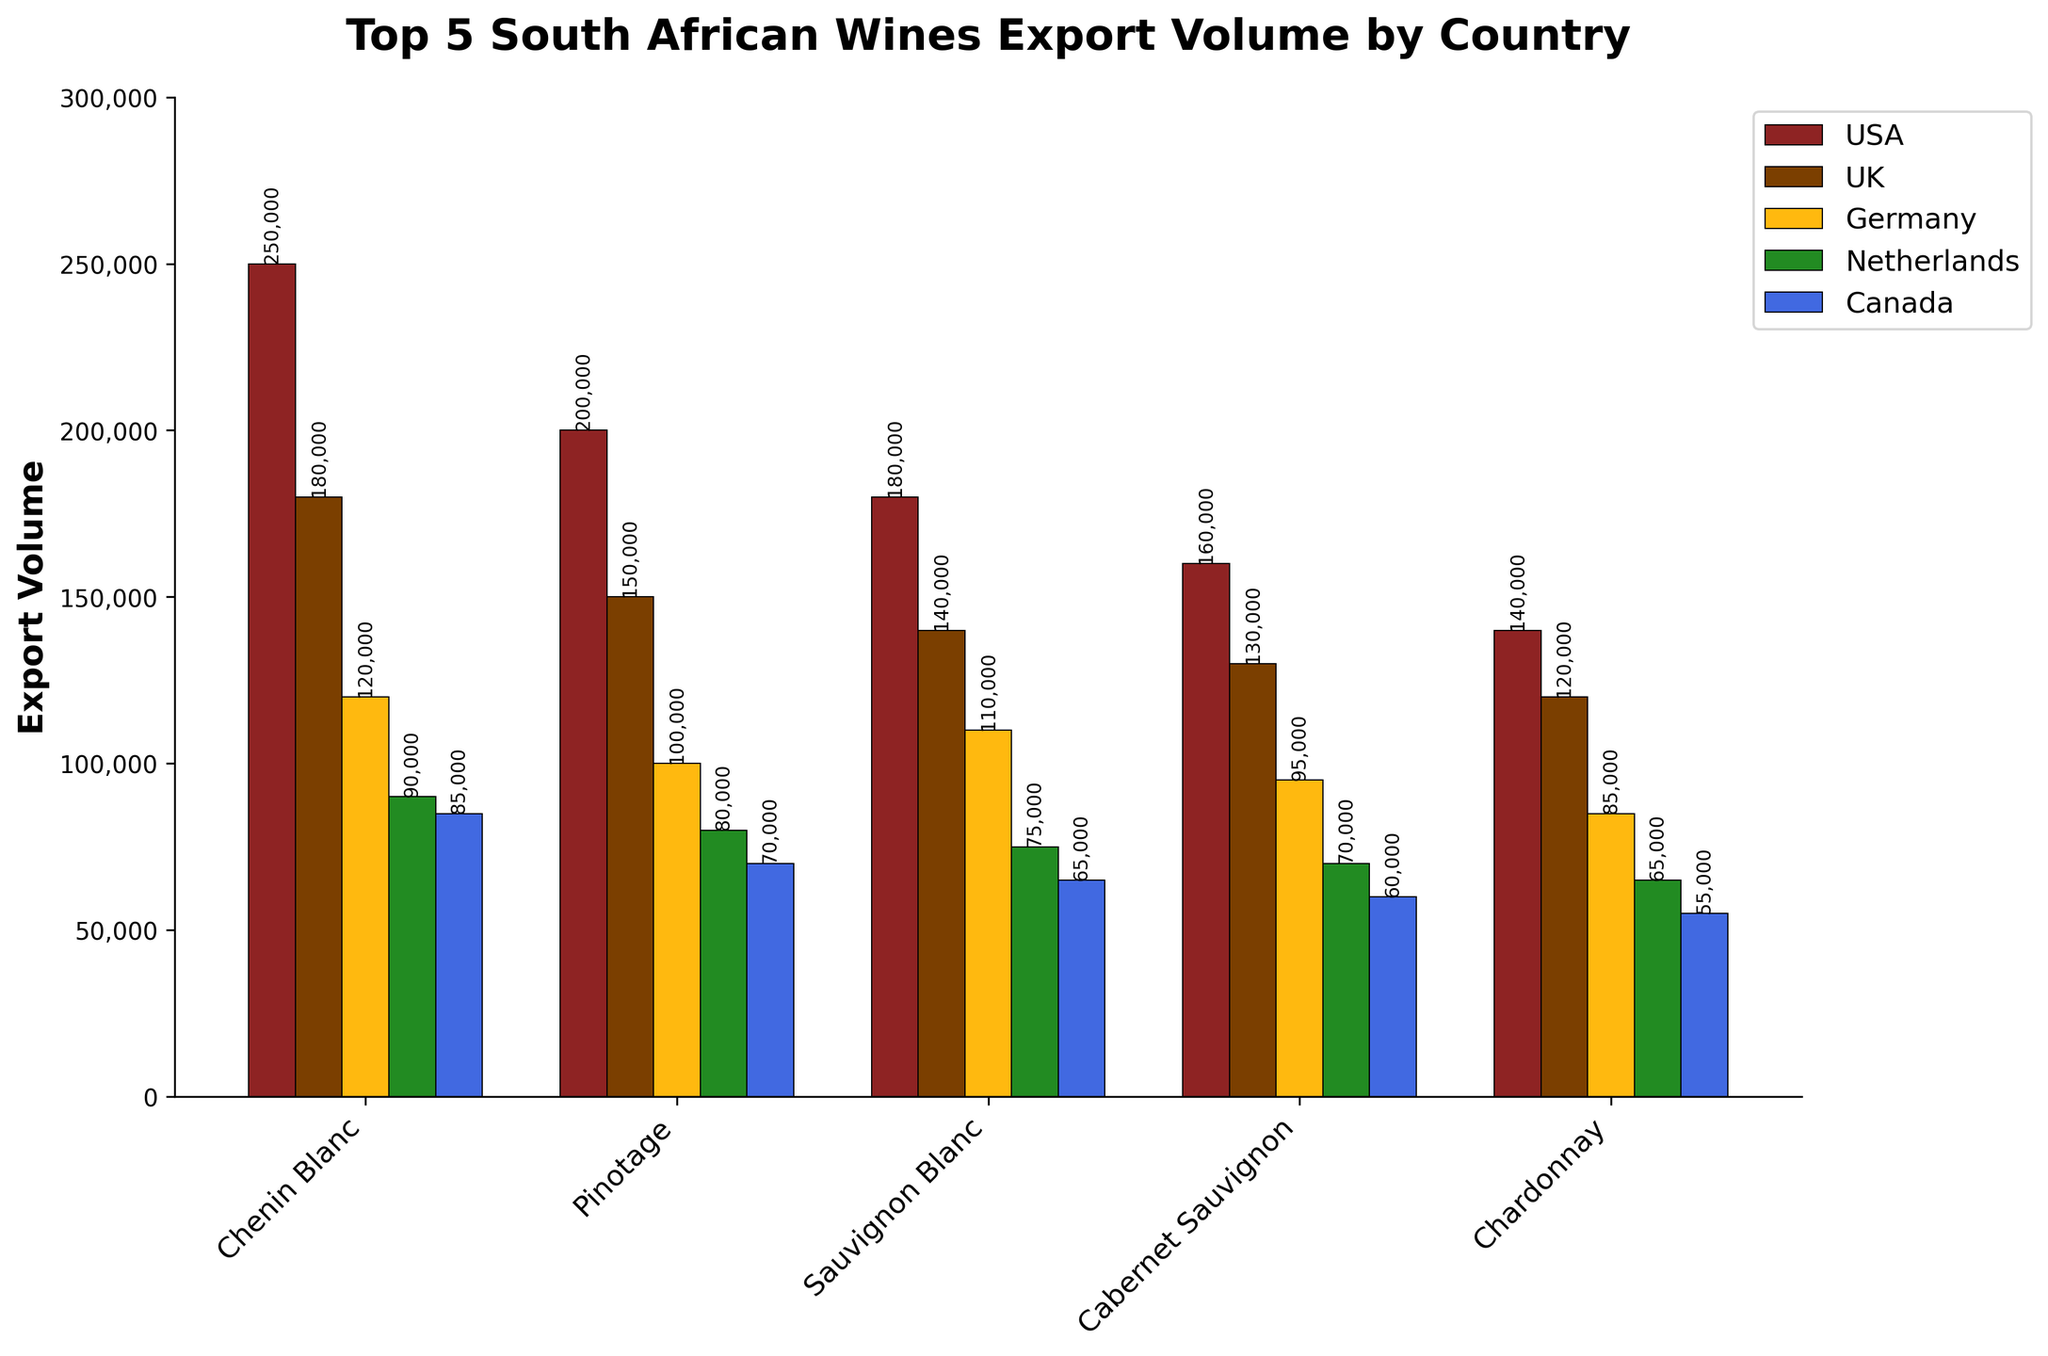Which wine has the highest export volume to the USA? By looking at the tallest bar in the USA category (first set of bars in red), Chenin Blanc stands out as the highest.
Answer: Chenin Blanc Which country receives the least export volume of Pinotage? Looking at the bars for Pinotage, the shortest bar is associated with Canada.
Answer: Canada How much more Chenin Blanc is exported to the USA compared to Germany? The export volume of Chenin Blanc to the USA is 250,000, whereas to Germany, it is 120,000. The difference is 250,000 - 120,000 = 130,000.
Answer: 130,000 What is the total export volume of Cabernet Sauvignon across all countries? Summing up the volumes of Cabernet Sauvignon: 160,000 (USA) + 130,000 (UK) + 95,000 (Germany) + 70,000 (Netherlands) + 60,000 (Canada) = 515,000.
Answer: 515,000 Which wine has the smallest overall export volume? Comparing the heights of the bars for each wine across all countries, Chardonnay consistently shows the shortest bars.
Answer: Chardonnay On average, which wine is most favored by European countries (UK, Germany, Netherlands)? Calculate the average export volume for each wine to UK, Germany, and Netherlands, then compare:
Chenin Blanc: (180,000 + 120,000 + 90,000) / 3 = 130,000 
Pinotage: (150,000 + 100,000 + 80,000) / 3 = 110,000
Sauvignon Blanc: (140,000 + 110,000 + 75,000) / 3 = 108,333
Cabernet Sauvignon: (130,000 + 95,000 + 70,000) / 3 = 98,333
Chardonnay: (120,000 + 85,000 + 65,000) / 3 = 90,000
Chenin Blanc has the highest average.
Answer: Chenin Blanc Which wine has a higher export volume to Canada than to the Netherlands? By comparing the bars for each wine, both Chenin Blanc and Sauvignon Blanc have higher export volumes to Canada than the Netherlands: 
Chenin Blanc: 85,000 (Canada) > 90,000 (Netherlands)
Sauvignon Blanc: 65,000 (Canada) < 75,000 (Netherlands) 
Therefore, Chenin Blanc.
Answer: Chenin Blanc What is the combined export volume of Sauvignon Blanc to the USA and the UK? Adding the export volumes to the USA and the UK: 180,000 (USA) + 140,000 (UK) = 320,000.
Answer: 320,000 Is the export volume of Pinotage to Germany greater than that of Cabernet Sauvignon to the USA? Comparing the individual bars: Pinotage to Germany is 100,000, while Cabernet Sauvignon to the USA is 160,000. The answer is 'no'.
Answer: No 